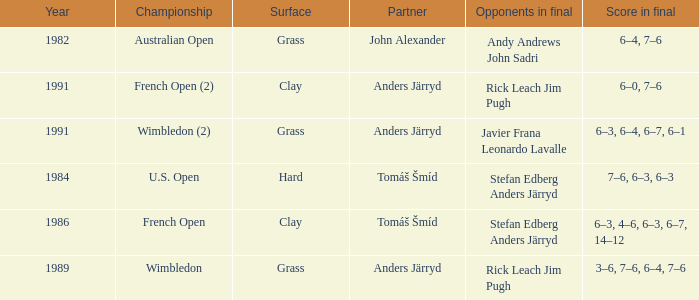What was the final score in 1986? 6–3, 4–6, 6–3, 6–7, 14–12. 